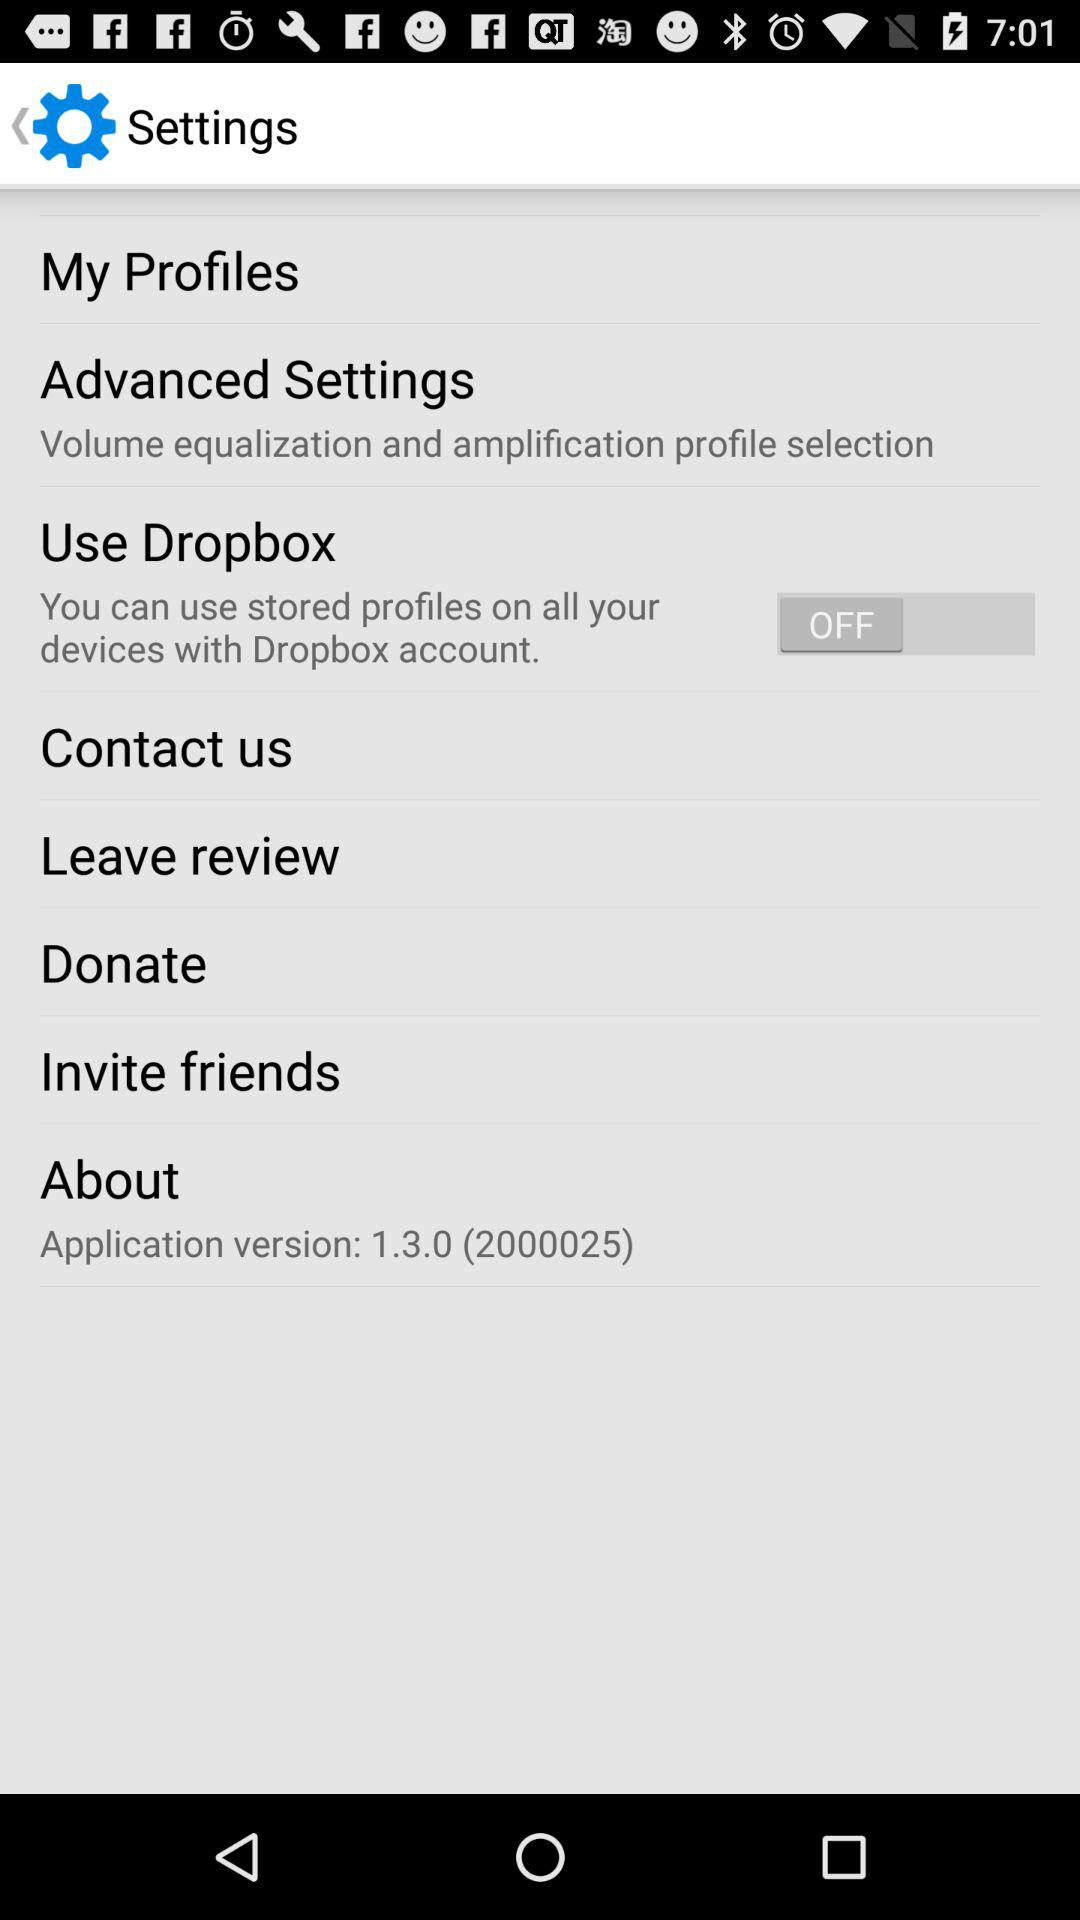What is the application version? The application version is 1.3.0 (2000025). 